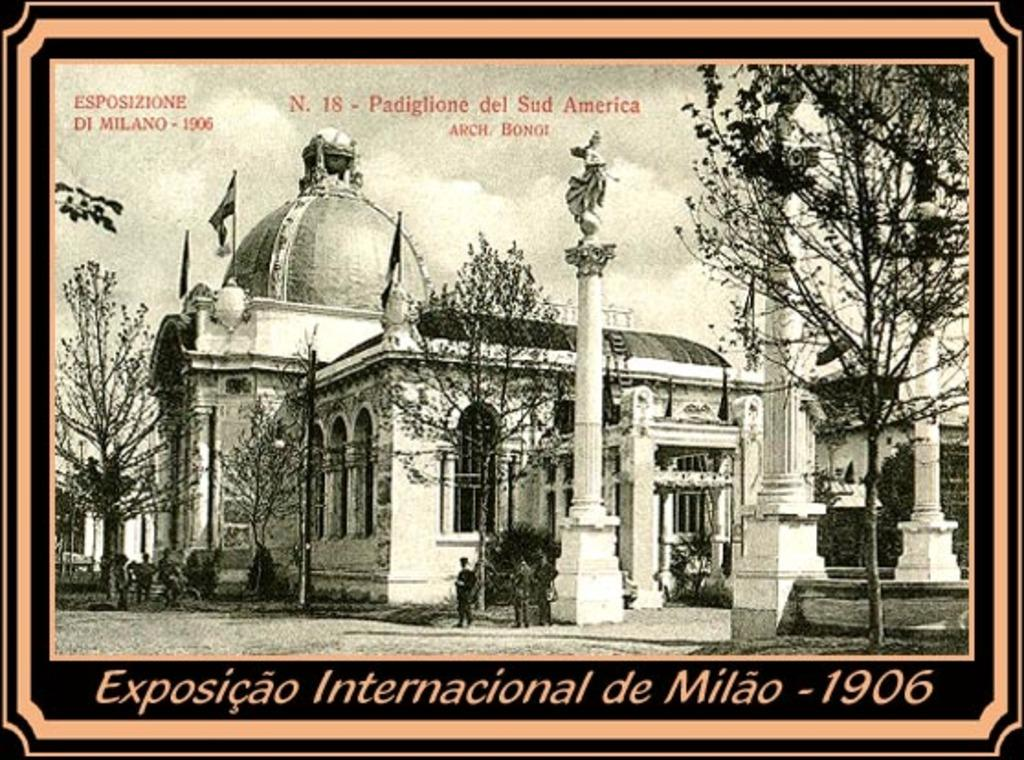What type of structures can be seen in the image? There are buildings in the image. What is the statue in the image depicting? The statue in the image is not specified, but it is present. What architectural elements are visible in the image? There are pillars in the image. What is flying in the sky in the image? There are flags in the image. What type of vegetation is present in the image? There are trees in the image. Are there any people visible in the image? Yes, there are people in the image. What can be used for entering or exiting the buildings in the image? There are doors in the image. What is visible in the background of the image? The sky is visible in the image, and there are clouds present. Is there any text present in the image? Yes, there is text at the bottom and top of the image. Can you tell me how many cars are parked near the statue in the image? There are no cars present in the image. What type of pest can be seen crawling on the pillars in the image? There are no pests visible in the image; only the buildings, statue, pillars, flags, trees, people, doors, sky, clouds, and text are present. 